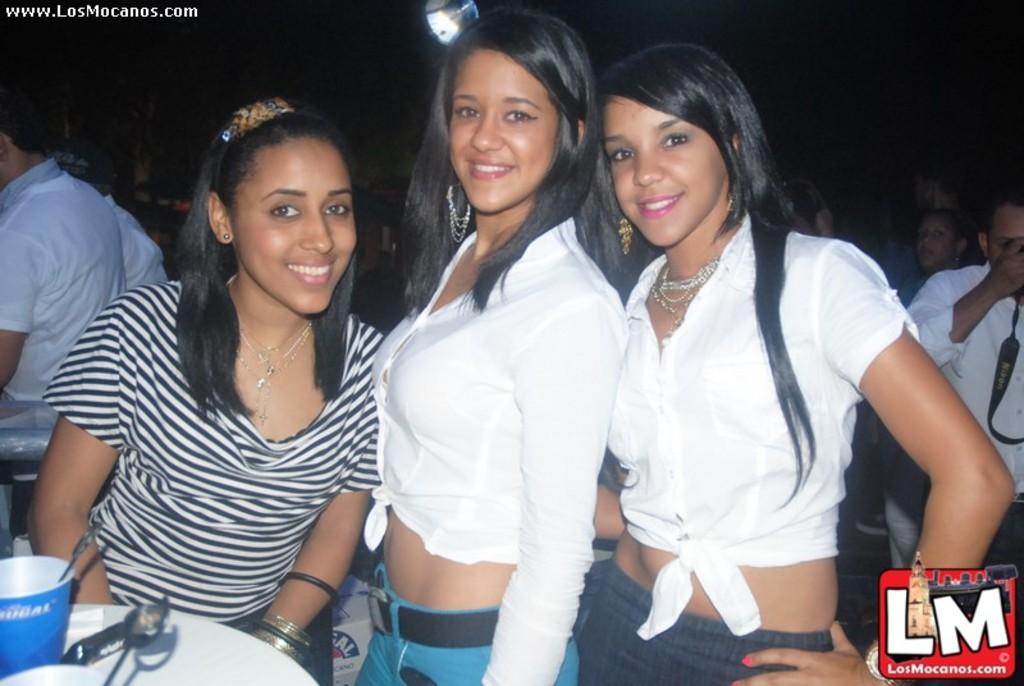What is the name of the company that took this?
Your response must be concise. Lm. 